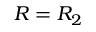Convert formula to latex. <formula><loc_0><loc_0><loc_500><loc_500>R = R _ { 2 }</formula> 